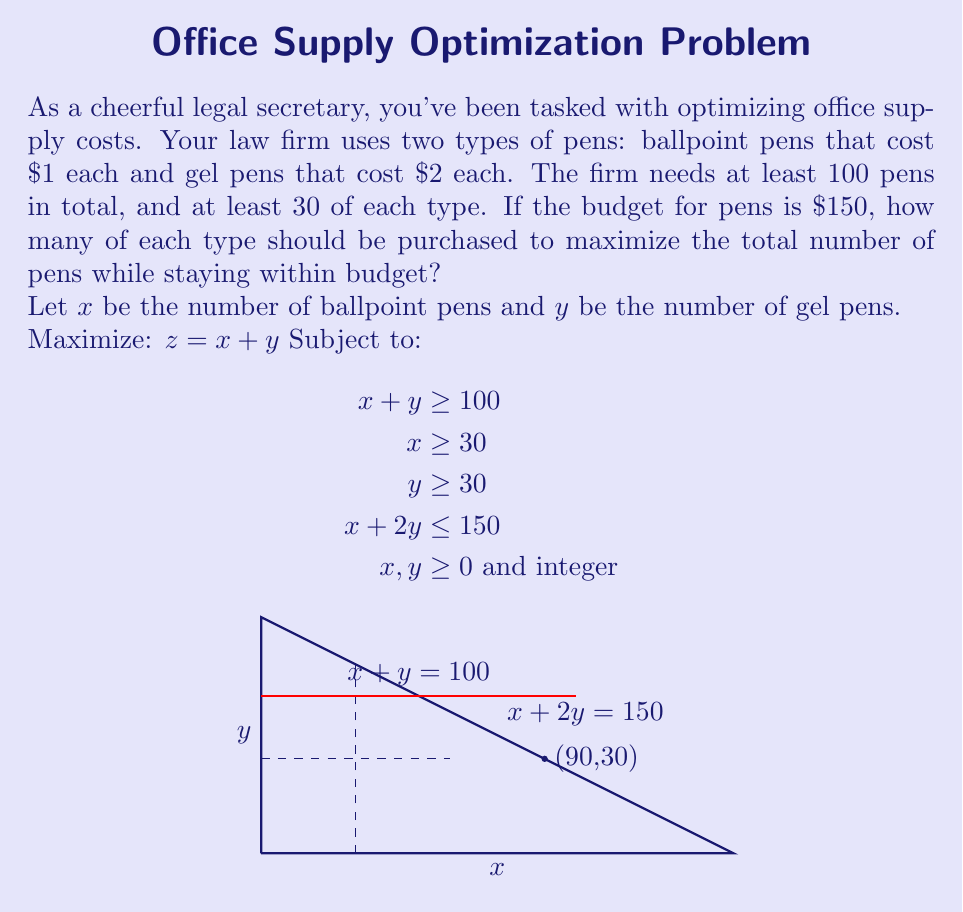What is the answer to this math problem? Let's approach this step-by-step:

1) We need to maximize $z = x + y$ subject to the given constraints.

2) From the graph, we can see that the feasible region is bounded by the lines $x = 30$, $y = 30$, $x + y = 100$, and $x + 2y = 150$.

3) The optimal solution will be at one of the corner points of this feasible region. The relevant corner points are:
   - (90, 30): intersection of $y = 30$ and $x + 2y = 150$
   - (70, 40): intersection of $x + y = 100$ and $x + 2y = 150$

4) Let's evaluate $z = x + y$ at these points:
   - At (90, 30): $z = 90 + 30 = 120$
   - At (70, 40): $z = 70 + 40 = 110$

5) The maximum value of $z$ occurs at (90, 30).

6) Therefore, the optimal solution is to purchase 90 ballpoint pens and 30 gel pens.

7) Let's verify the constraints:
   - Total pens: $90 + 30 = 120 \geq 100$
   - At least 30 of each: Satisfied
   - Budget: $90(1) + 30(2) = 90 + 60 = 150 \leq 150$

Thus, this solution maximizes the number of pens while satisfying all constraints.
Answer: 90 ballpoint pens, 30 gel pens 